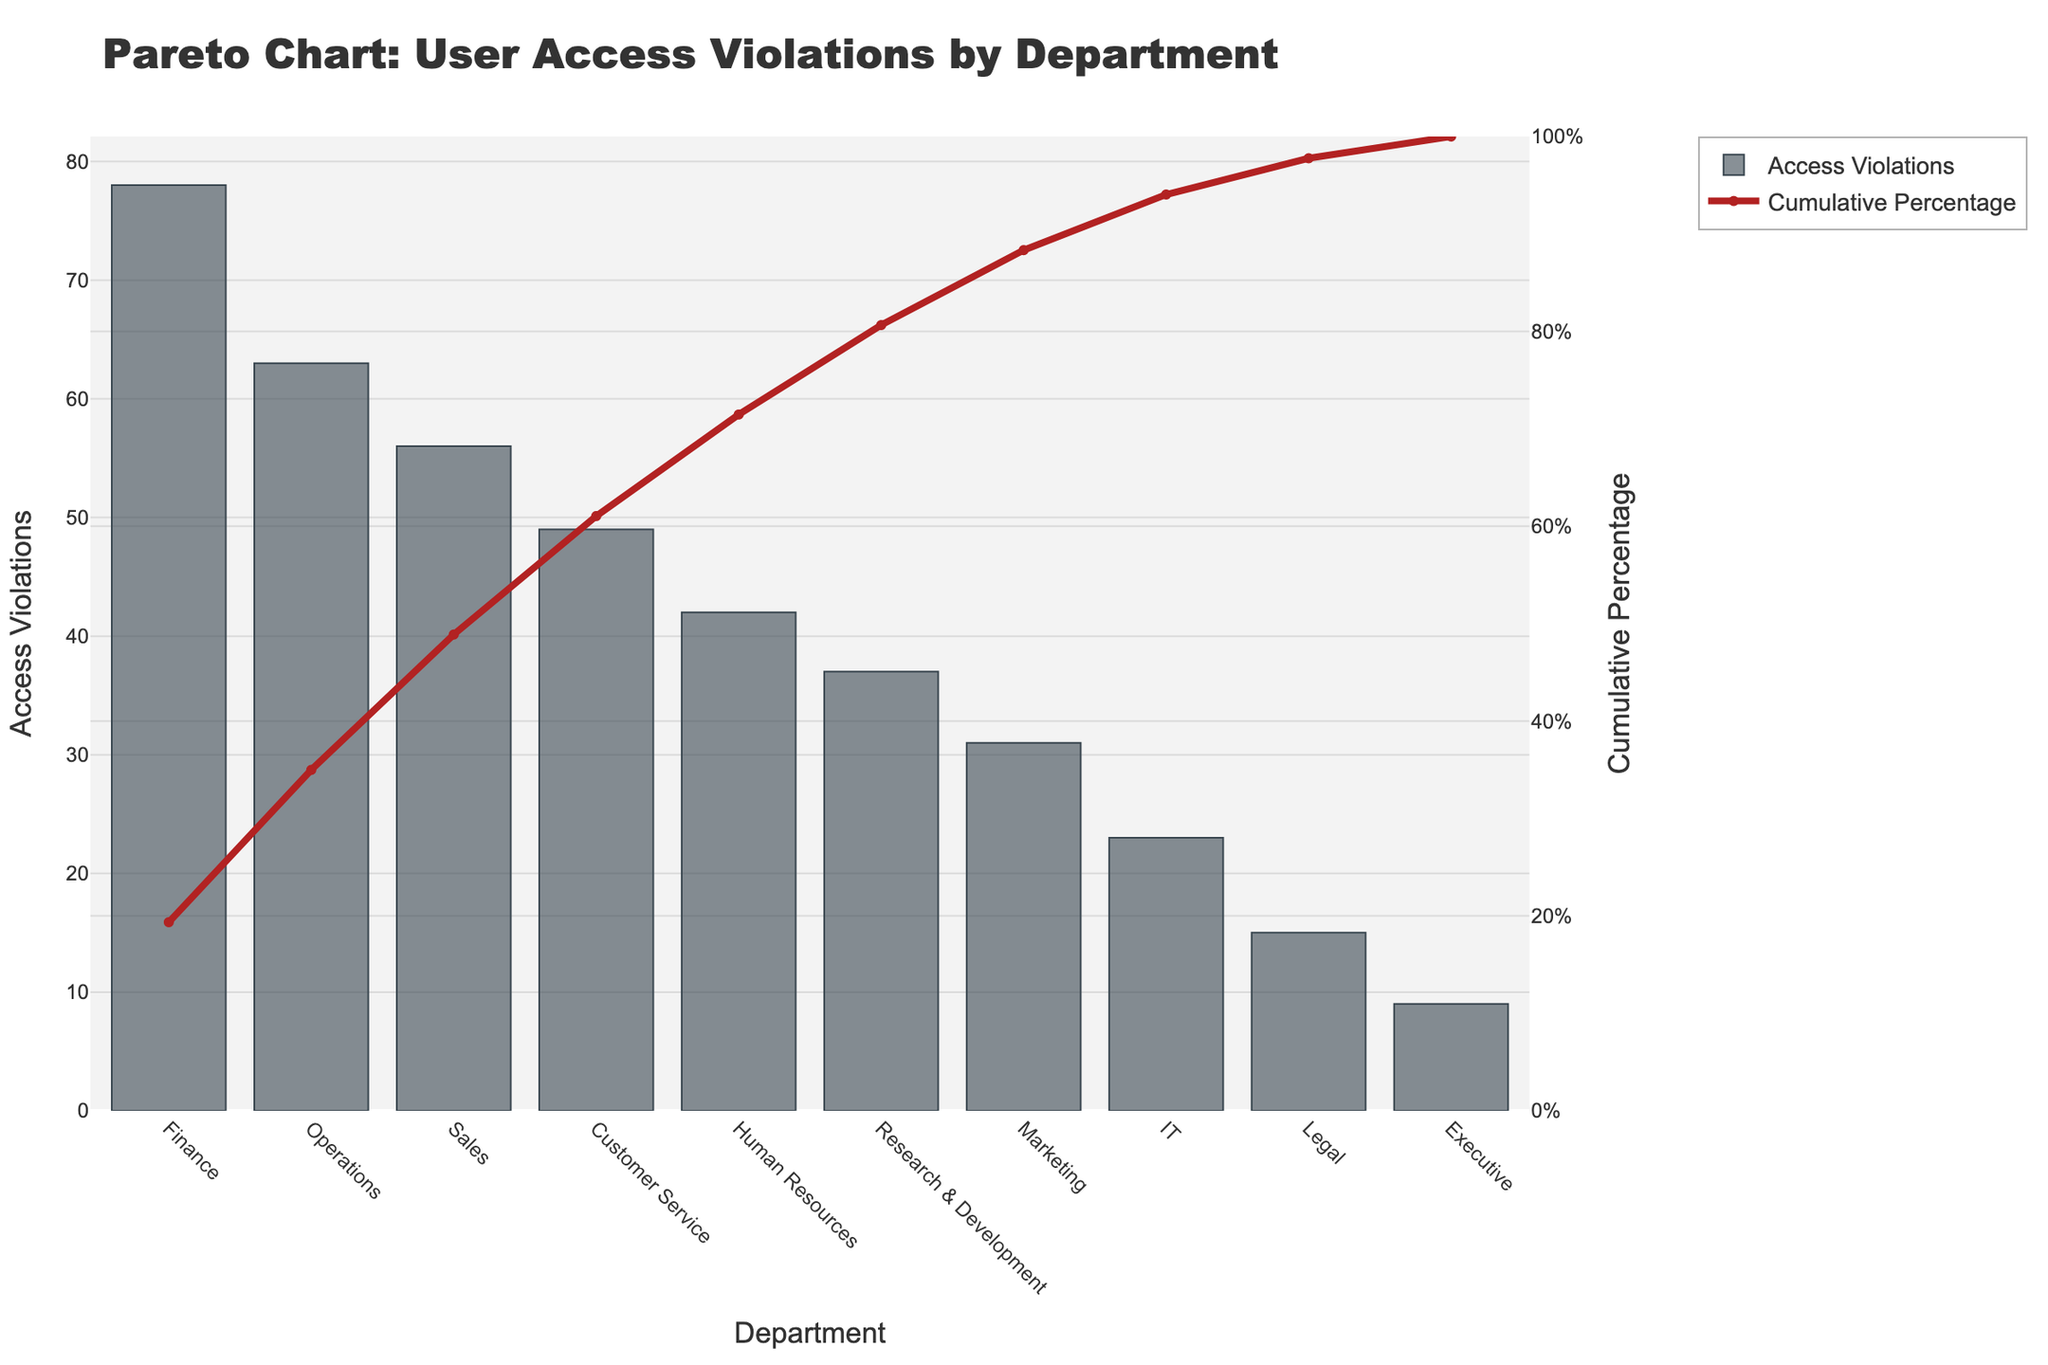What is the title of the figure? The title is located at the top of the figure and provides a summary of what the chart represents.
Answer: Pareto Chart: User Access Violations by Department Which department has the highest number of access violations? The tallest bar in the chart represents the department with the highest number of access violations.
Answer: Finance How many departments have more than 50 access violations? By observing the heights of the bars and identifying those that surpass the 50 access violations mark on the primary y-axis, we can count the number of departments. Finance, Sales, and Operations each have more than 50 access violations.
Answer: 3 What is the cumulative percentage of access violations for IT and Marketing departments combined? From the chart, locate the cumulative percentages corresponding to IT and Marketing. Then, add these percentages together: IT's cumulative percentage (~87.17) + Marketing's cumulative percentage (~58.43 - 37.98) = 87.17%.
Answer: ~87.17% Which department contributes to around 80% of the cumulative access violations? Identify the point on the cumulative percentage line that is around 80%. Then, trace this point downwards to see which department it aligns with.
Answer: Customer Service What are the access violations for the department with the second-lowest violations? First, identify the department with the second-shortest bar, which is above the smallest one. This department is Executive. Then find the count of access violations for the Legal department.
Answer: 15 How does the number of violations in Operations compare to those in Human Resources? Compare the heights of the bars for Operations and Human Resources on the primary y-axis. Operations has 63 access violations, whereas Human Resources has 42. Thus, Operations has 63 - 42 = 21 more access violations.
Answer: 21 more violations What is the rank of the Research & Development department in terms of access violations? Research & Development's bar height compared within the sorted values places it in order: Finance, Operations, Sales, Customer Service, Human Resources, Research & Development, Marketing, IT, Legal, Executive. Research & Development is 6th.
Answer: 6th Which department is closest to contributing 20% of cumulative access violations? Check the cumulative percentage line to see which department aligns closest to the 20% mark.
Answer: Customer Service 